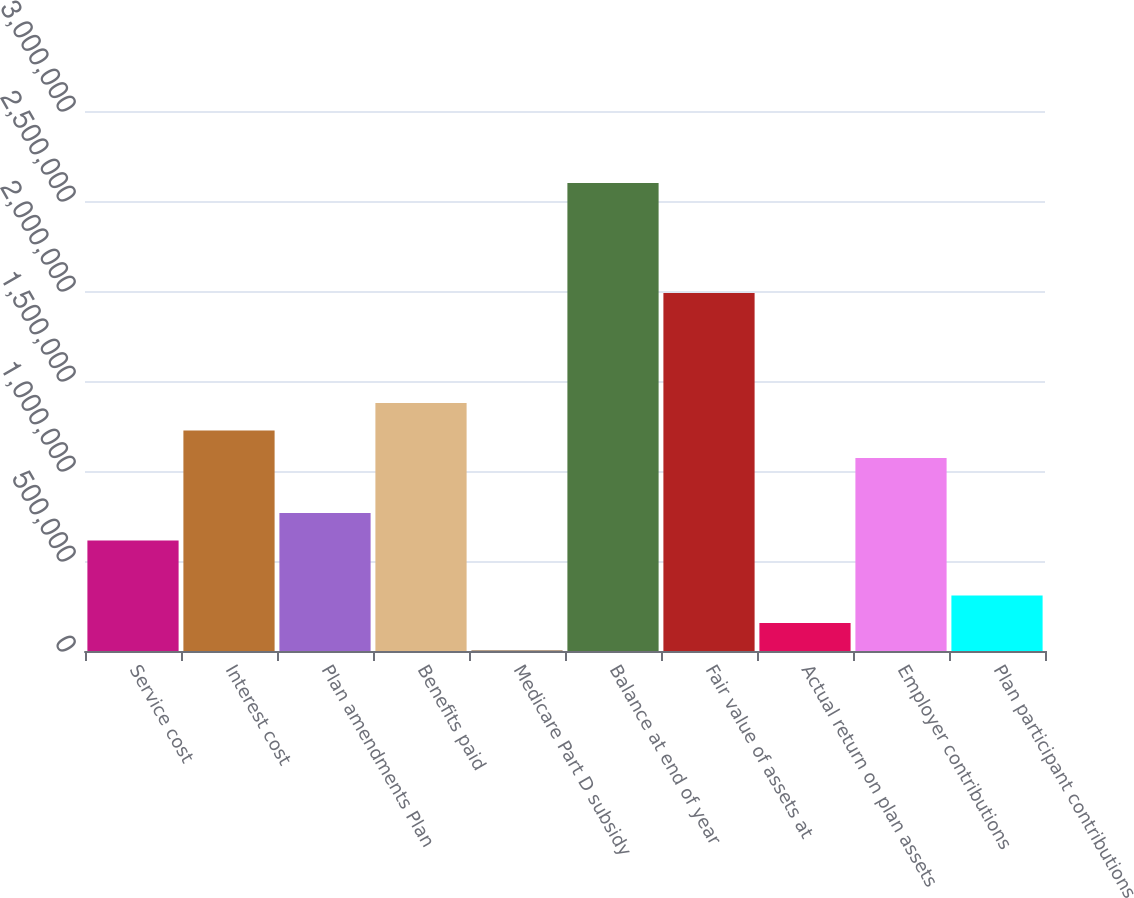Convert chart. <chart><loc_0><loc_0><loc_500><loc_500><bar_chart><fcel>Service cost<fcel>Interest cost<fcel>Plan amendments Plan<fcel>Benefits paid<fcel>Medicare Part D subsidy<fcel>Balance at end of year<fcel>Fair value of assets at<fcel>Actual return on plan assets<fcel>Employer contributions<fcel>Plan participant contributions<nl><fcel>614237<fcel>1.2253e+06<fcel>767002<fcel>1.37806e+06<fcel>3175<fcel>2.60019e+06<fcel>1.98913e+06<fcel>155940<fcel>1.07253e+06<fcel>308706<nl></chart> 